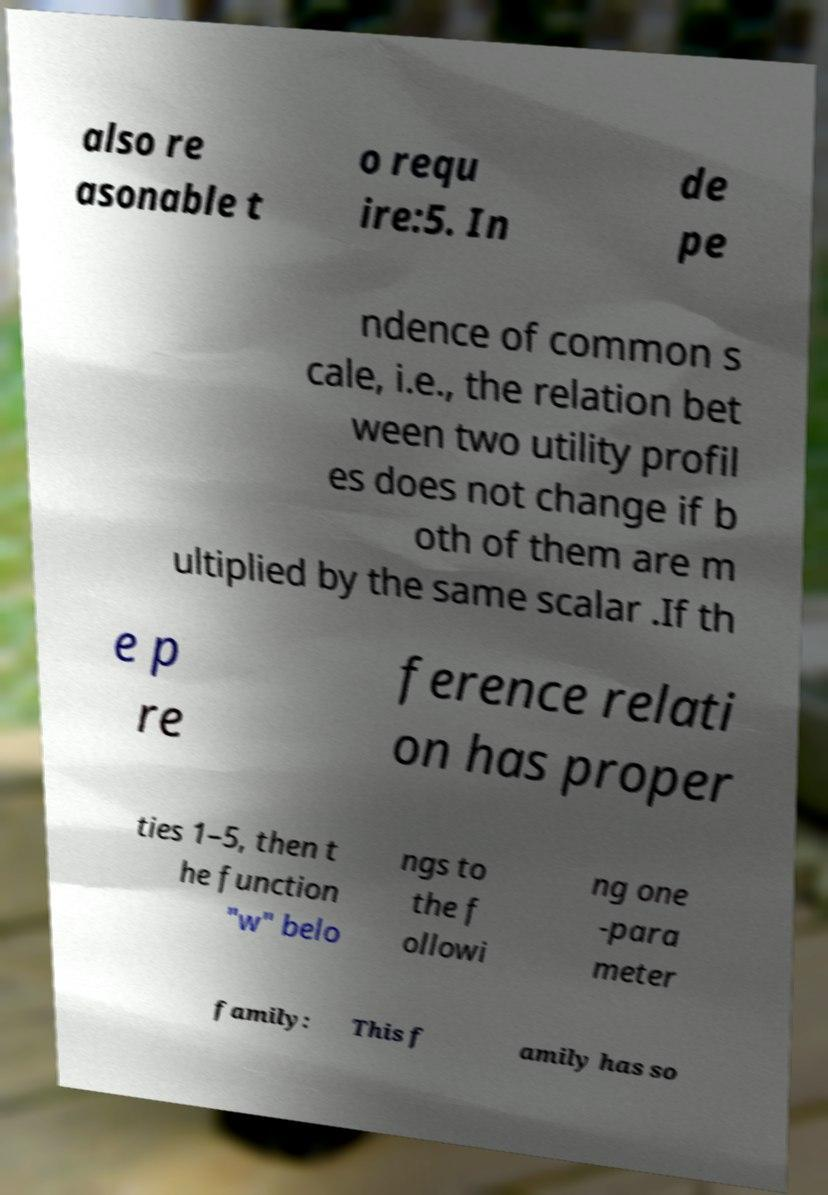For documentation purposes, I need the text within this image transcribed. Could you provide that? also re asonable t o requ ire:5. In de pe ndence of common s cale, i.e., the relation bet ween two utility profil es does not change if b oth of them are m ultiplied by the same scalar .If th e p re ference relati on has proper ties 1–5, then t he function "w" belo ngs to the f ollowi ng one -para meter family: This f amily has so 